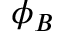<formula> <loc_0><loc_0><loc_500><loc_500>\phi _ { B }</formula> 